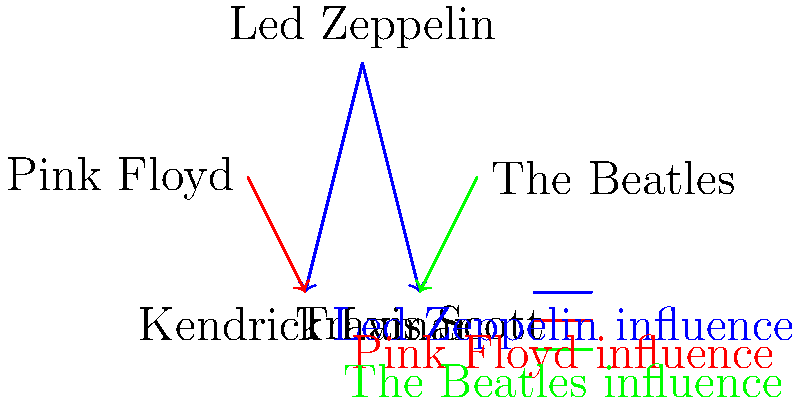Based on the vector-based network diagram showing the influence of classic rock artists on modern rappers, which classic rock band appears to have the most widespread influence on the depicted modern rap artists? To determine which classic rock band has the most widespread influence, we need to analyze the connections in the diagram:

1. Led Zeppelin:
   - Influences Kendrick Lamar (blue arrow)
   - Influences Travis Scott (blue arrow)
   - Total: 2 connections

2. Pink Floyd:
   - Influences Kendrick Lamar (red arrow)
   - Total: 1 connection

3. The Beatles:
   - Influences Travis Scott (green arrow)
   - Total: 1 connection

Led Zeppelin has connections to both modern rappers depicted in the diagram (Kendrick Lamar and Travis Scott), while Pink Floyd and The Beatles only influence one rapper each.

Therefore, Led Zeppelin appears to have the most widespread influence among the classic rock bands shown in the diagram.
Answer: Led Zeppelin 